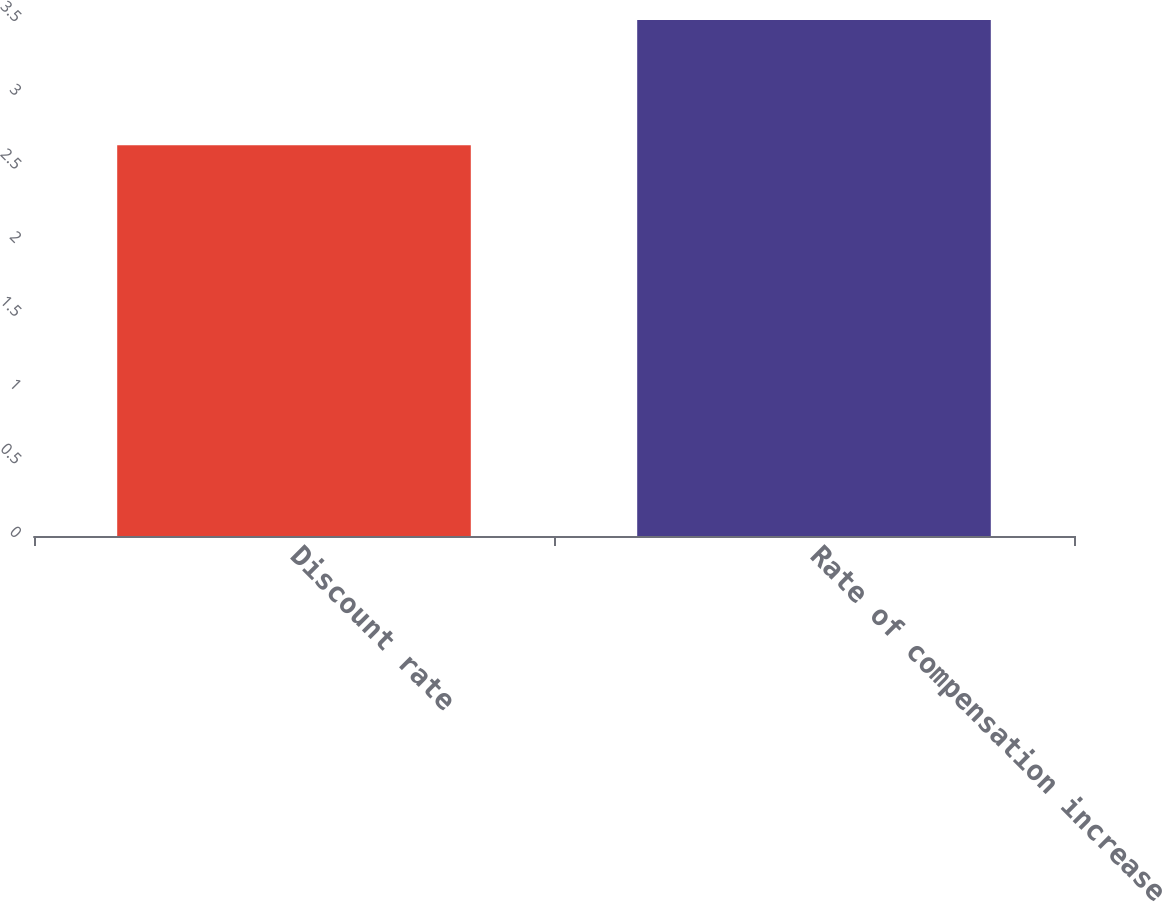<chart> <loc_0><loc_0><loc_500><loc_500><bar_chart><fcel>Discount rate<fcel>Rate of compensation increase<nl><fcel>2.65<fcel>3.5<nl></chart> 